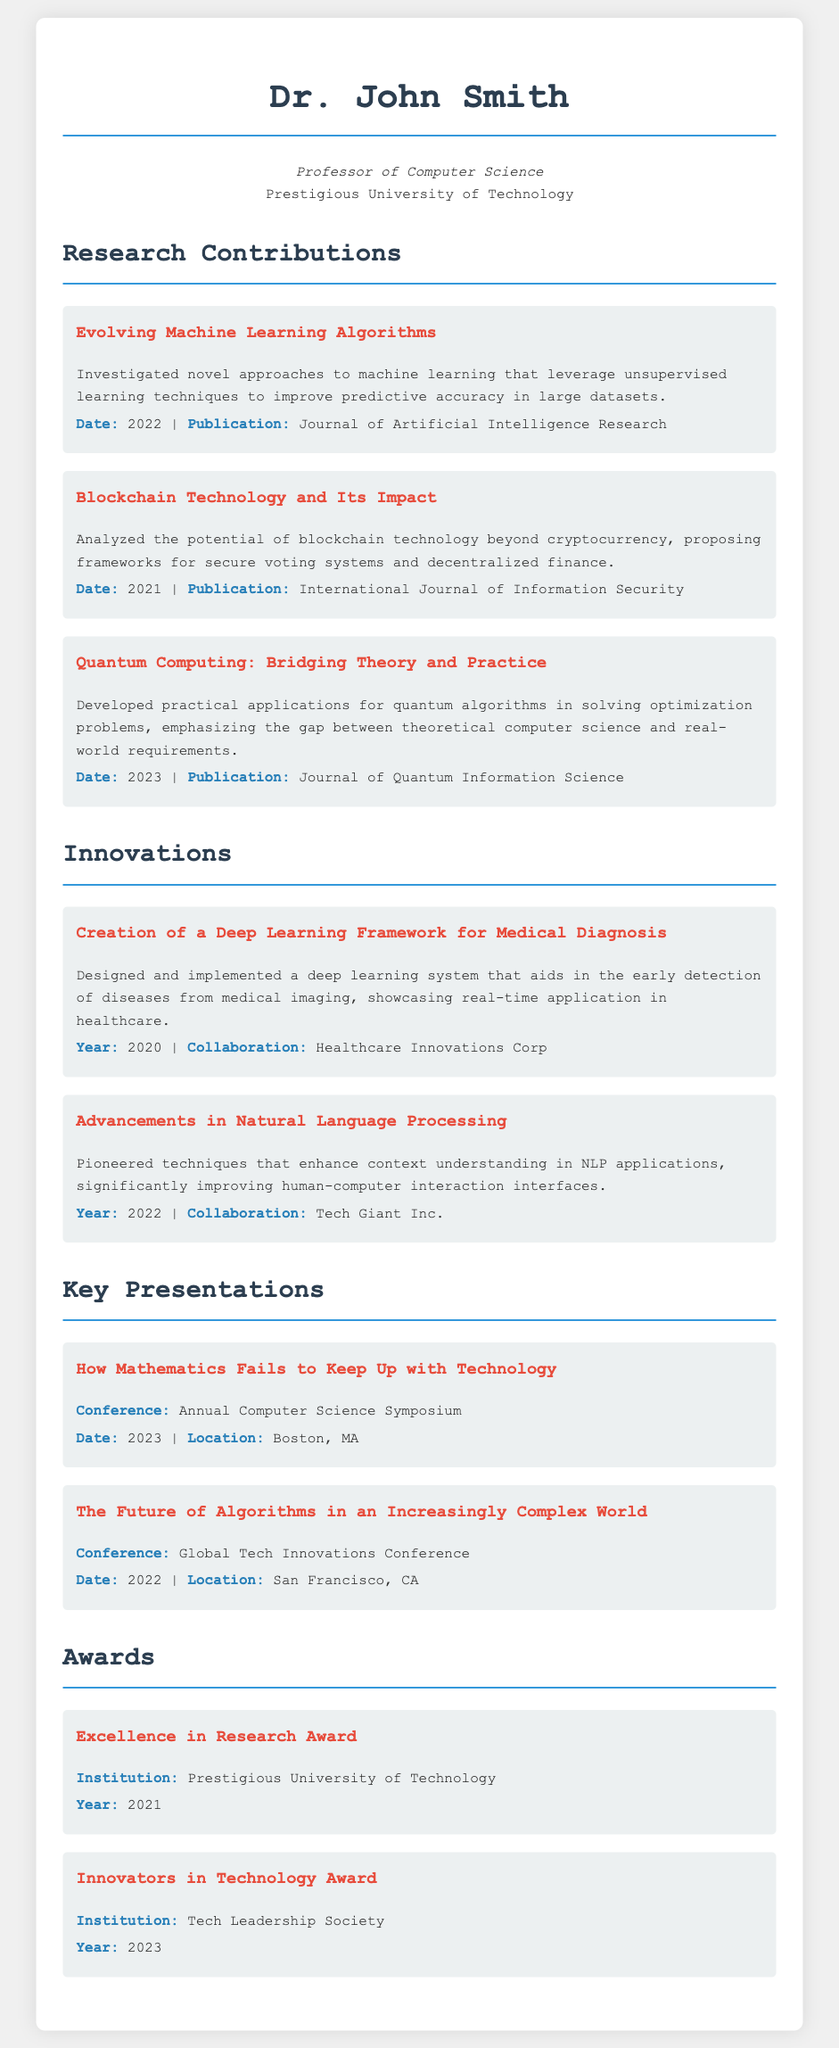What is the name of the professor? The professor's name is stated prominently at the top of the document.
Answer: Dr. John Smith What is the publication date for the paper on Quantum Computing? The date is listed under the corresponding research contribution about Quantum Computing.
Answer: 2023 Which journal published the research on Evolving Machine Learning Algorithms? The publication name is provided with the date for this research contribution.
Answer: Journal of Artificial Intelligence Research In what year was the Deep Learning Framework for Medical Diagnosis created? The year is specified in the innovations section related to the medical diagnosis framework.
Answer: 2020 Who collaborated with Dr. John Smith on advancements in Natural Language Processing? The collaboration information is mentioned alongside the description of the NLP advancements.
Answer: Tech Giant Inc What is the title of the presentation given in 2023? The title is explicitly provided along with the date in the key presentations section.
Answer: How Mathematics Fails to Keep Up with Technology Which award did Dr. John Smith receive in 2021? The specific award is mentioned under the awards section with the year indicated.
Answer: Excellence in Research Award What framework was proposed in the research on Blockchain Technology? The type of framework is detailed in the concise description of the blockchain research.
Answer: Secure voting systems and decentralized finance What does Dr. John Smith argue about mathematics in his presentations? His argument is summarized in the title of one of the presentations he gave.
Answer: Fails to keep up with technology 